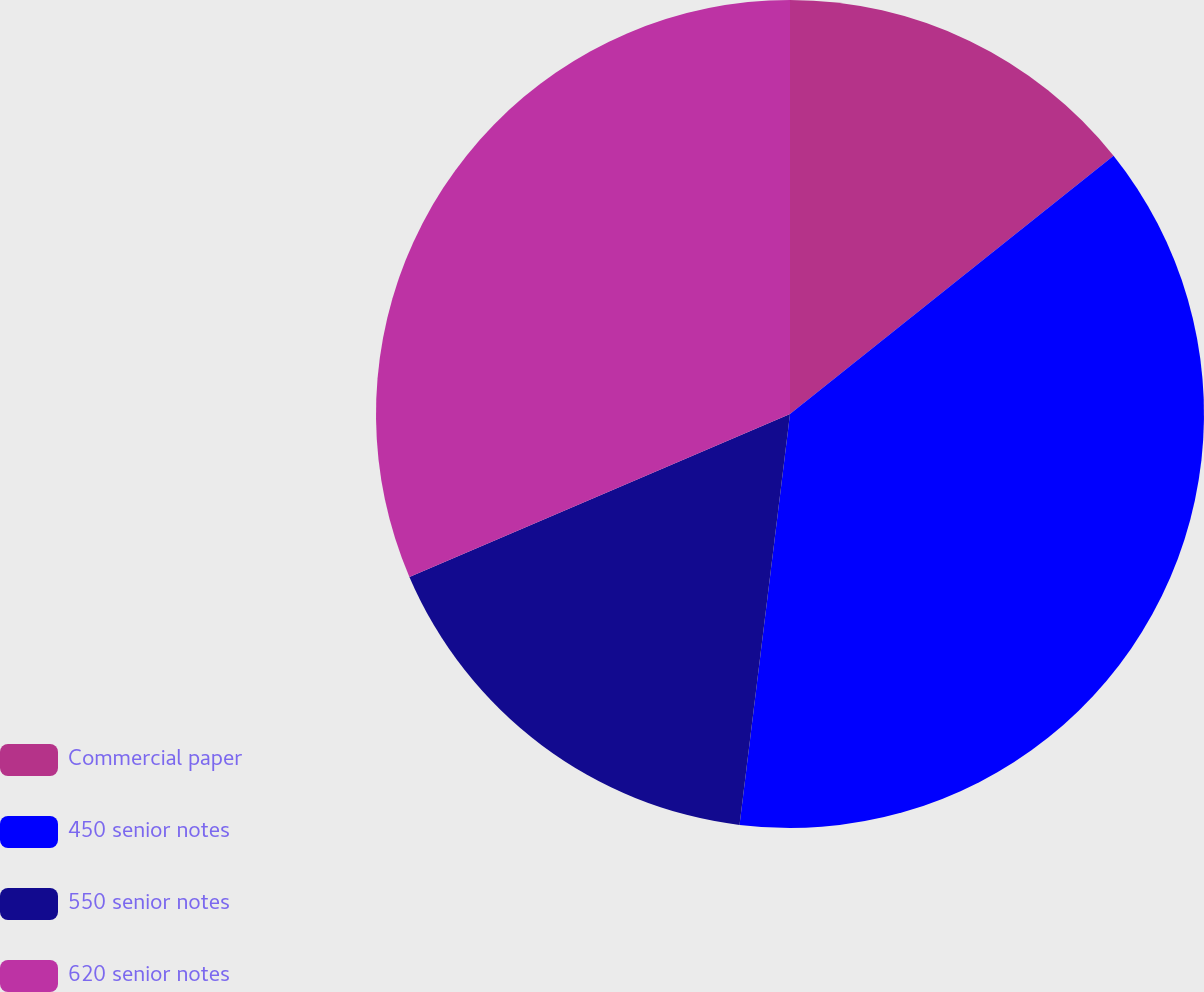Convert chart to OTSL. <chart><loc_0><loc_0><loc_500><loc_500><pie_chart><fcel>Commercial paper<fcel>450 senior notes<fcel>550 senior notes<fcel>620 senior notes<nl><fcel>14.28%<fcel>37.67%<fcel>16.62%<fcel>31.44%<nl></chart> 